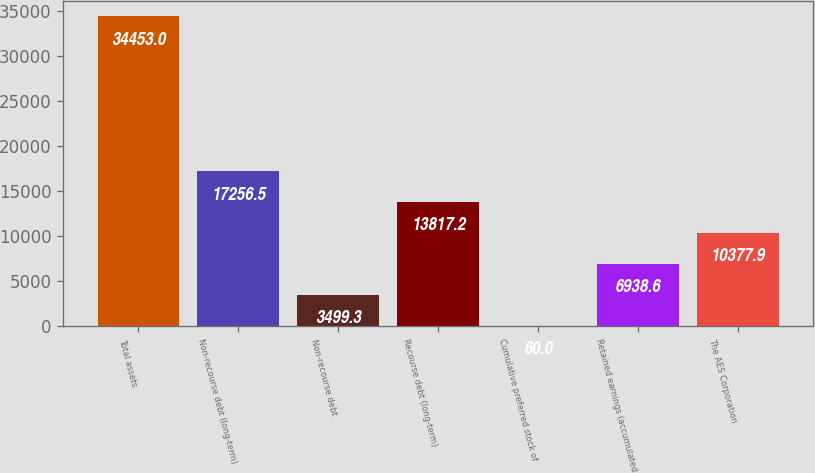<chart> <loc_0><loc_0><loc_500><loc_500><bar_chart><fcel>Total assets<fcel>Non-recourse debt (long-term)<fcel>Non-recourse debt<fcel>Recourse debt (long-term)<fcel>Cumulative preferred stock of<fcel>Retained earnings (accumulated<fcel>The AES Corporation<nl><fcel>34453<fcel>17256.5<fcel>3499.3<fcel>13817.2<fcel>60<fcel>6938.6<fcel>10377.9<nl></chart> 